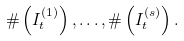Convert formula to latex. <formula><loc_0><loc_0><loc_500><loc_500>\# \left ( I _ { t } ^ { ( 1 ) } \right ) , \dots , \# \left ( I _ { t } ^ { ( s ) } \right ) .</formula> 